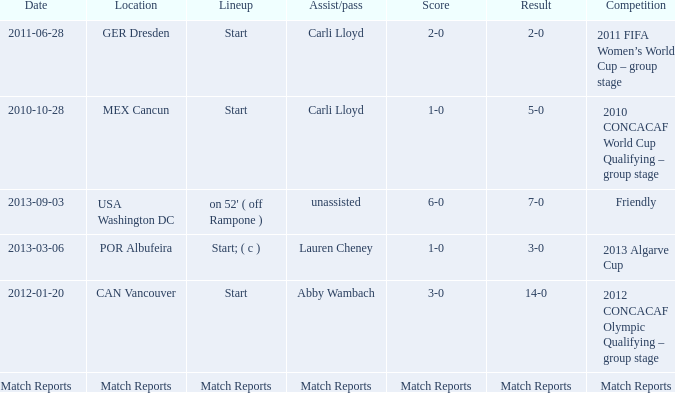Which score has a location of mex cancun? 1-0. 